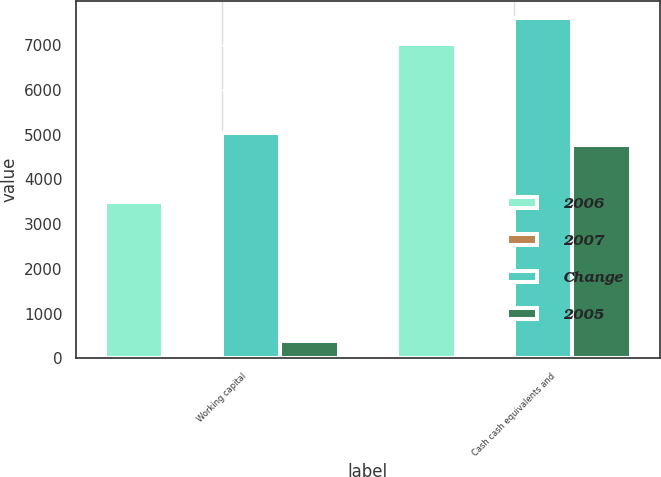Convert chart. <chart><loc_0><loc_0><loc_500><loc_500><stacked_bar_chart><ecel><fcel>Working capital<fcel>Cash cash equivalents and<nl><fcel>2006<fcel>3496<fcel>7020<nl><fcel>2007<fcel>31<fcel>8<nl><fcel>Change<fcel>5044<fcel>7605<nl><fcel>2005<fcel>385<fcel>4771<nl></chart> 